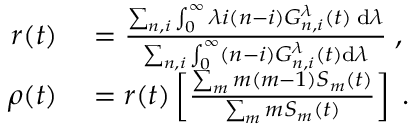<formula> <loc_0><loc_0><loc_500><loc_500>\begin{array} { r l } { r ( t ) } & = \frac { \sum _ { n , i } \int _ { 0 } ^ { \infty } \lambda i ( n - i ) G _ { n , i } ^ { \lambda } ( t ) \, d \lambda } { \sum _ { n , i } \int _ { 0 } ^ { \infty } ( n - i ) G _ { n , i } ^ { \lambda } ( t ) d \lambda } \, , } \\ { \rho ( t ) } & = r ( t ) \left [ \frac { \sum _ { m } m ( m - 1 ) S _ { m } ( t ) } { \sum _ { m } m S _ { m } ( t ) } \right ] \, . } \end{array}</formula> 